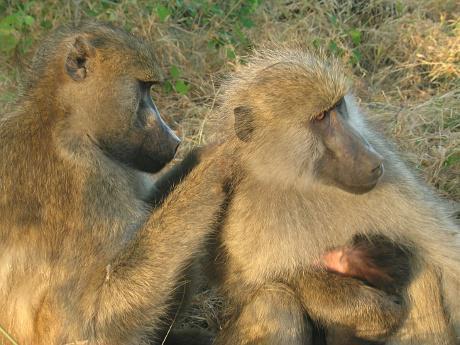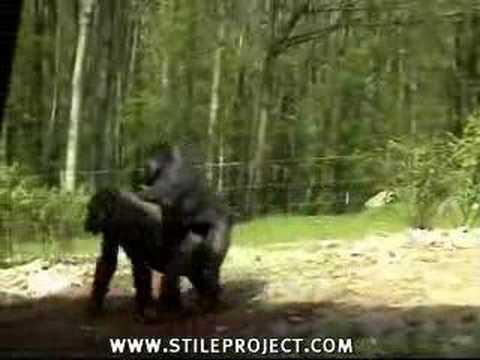The first image is the image on the left, the second image is the image on the right. Given the left and right images, does the statement "No image contains more than three monkeys, and one image shows a monkey with both paws grooming the fur of the monkey next to it." hold true? Answer yes or no. Yes. The first image is the image on the left, the second image is the image on the right. Analyze the images presented: Is the assertion "There are exactly two animals visible in the right image." valid? Answer yes or no. Yes. 